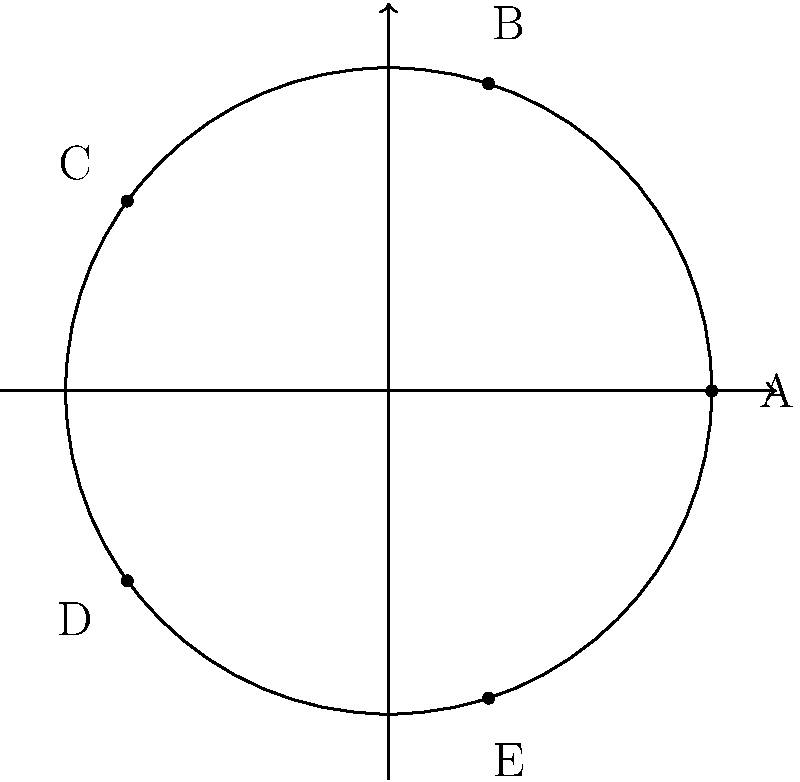In a cricket team's batting order, five players (A, B, C, D, and E) form a cyclic group under the operation of rotation. If rotating the order once moves each player to the next position (with the last player moving to the first position), how many rotations are needed to return to the original order? What is the order of this cyclic group? To solve this problem, let's follow these steps:

1) First, we need to understand what happens with each rotation:
   Original: A → B → C → D → E
   After 1 rotation: E → A → B → C → D
   After 2 rotations: D → E → A → B → C
   And so on...

2) We need to find how many rotations it takes to get back to the original order.

3) Let's count:
   - 1 rotation: E A B C D
   - 2 rotations: D E A B C
   - 3 rotations: C D E A B
   - 4 rotations: B C D E A
   - 5 rotations: A B C D E

4) We see that after 5 rotations, we're back to the original order.

5) In group theory, the number of elements in a group is called its order.

6) Since it takes 5 rotations to return to the original state, and there are 5 unique arrangements, this cyclic group has an order of 5.

7) This group is isomorphic to the cyclic group $C_5$ or $\mathbb{Z}_5$ (the integers modulo 5).
Answer: 5 